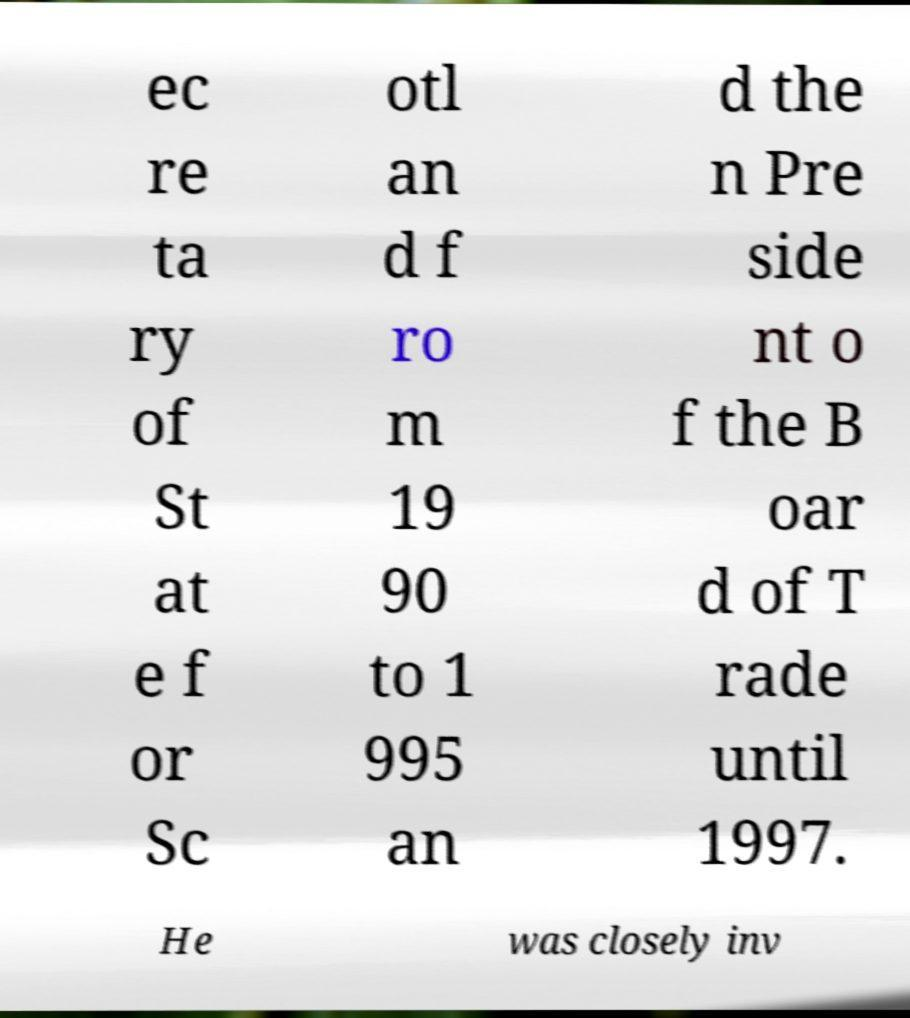Can you accurately transcribe the text from the provided image for me? ec re ta ry of St at e f or Sc otl an d f ro m 19 90 to 1 995 an d the n Pre side nt o f the B oar d of T rade until 1997. He was closely inv 